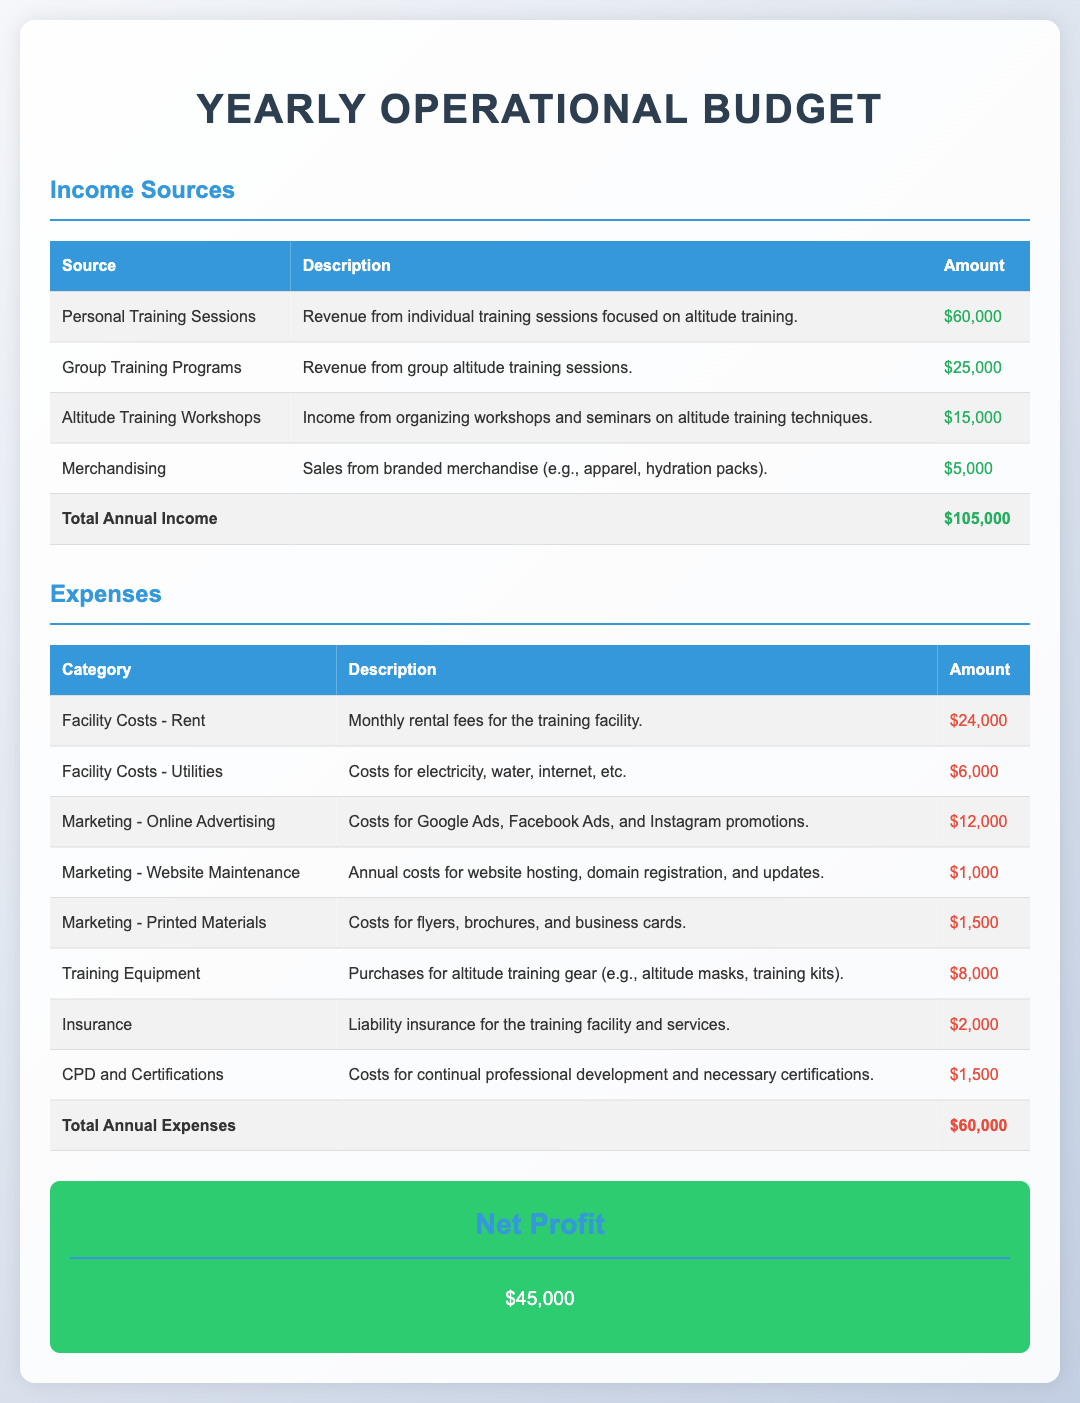what is the total annual income? The total annual income is the sum of all income sources in the document, which is $60,000 + $25,000 + $15,000 + $5,000.
Answer: $105,000 what category has the highest expense? The expense category with the highest amount is compared among all listed expenses. Facility Costs - Rent is $24,000.
Answer: Facility Costs - Rent how much is spent on marketing online advertising? The document lists Online Advertising under Marketing as $12,000.
Answer: $12,000 what is the total annual expenses? The total annual expenses are calculated by summing all expenses listed in the document, totaling $60,000.
Answer: $60,000 what is the net profit? The net profit is calculated as total income minus total expenses, $105,000 - $60,000.
Answer: $45,000 how much is allocated for training equipment? The amount allocated for Training Equipment is stated as $8,000 in the expense section.
Answer: $8,000 what is the expense for insurance? The document lists Insurance as having an expense of $2,000.
Answer: $2,000 how many income sources are listed in the document? The document lists four income sources related to the personal training business.
Answer: Four 